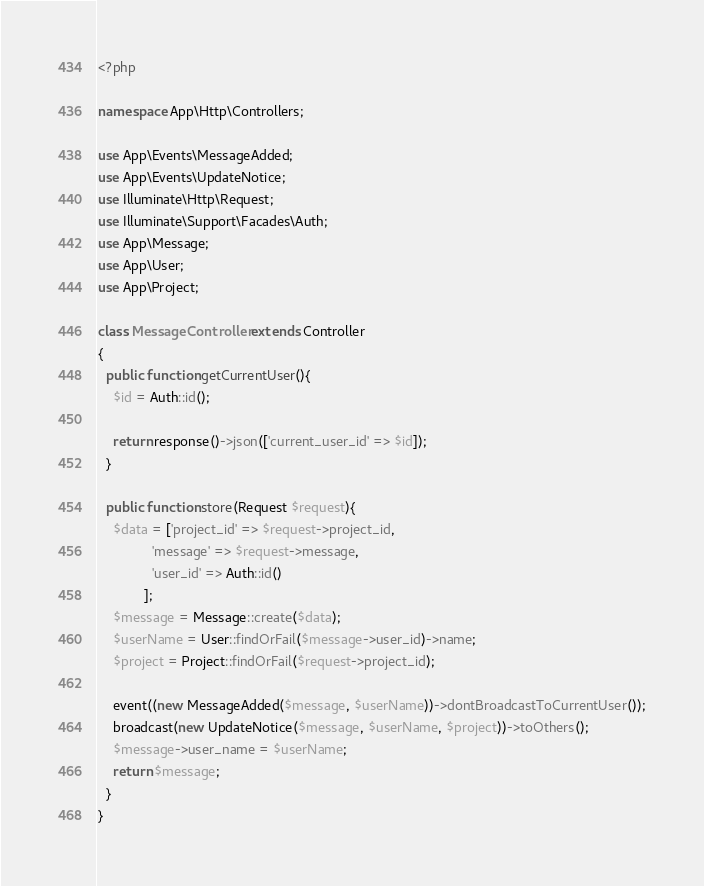<code> <loc_0><loc_0><loc_500><loc_500><_PHP_><?php

namespace App\Http\Controllers;

use App\Events\MessageAdded;
use App\Events\UpdateNotice;
use Illuminate\Http\Request;
use Illuminate\Support\Facades\Auth;
use App\Message;
use App\User;
use App\Project;

class MessageController extends Controller
{
  public function getCurrentUser(){    
    $id = Auth::id();
    
    return response()->json(['current_user_id' => $id]);
  }
  
  public function store(Request $request){
    $data = ['project_id' => $request->project_id,
              'message' => $request->message,
              'user_id' => Auth::id()
            ];
    $message = Message::create($data);
    $userName = User::findOrFail($message->user_id)->name;
    $project = Project::findOrFail($request->project_id);

    event((new MessageAdded($message, $userName))->dontBroadcastToCurrentUser());
    broadcast(new UpdateNotice($message, $userName, $project))->toOthers();
    $message->user_name = $userName;
    return $message;
  }
}
</code> 